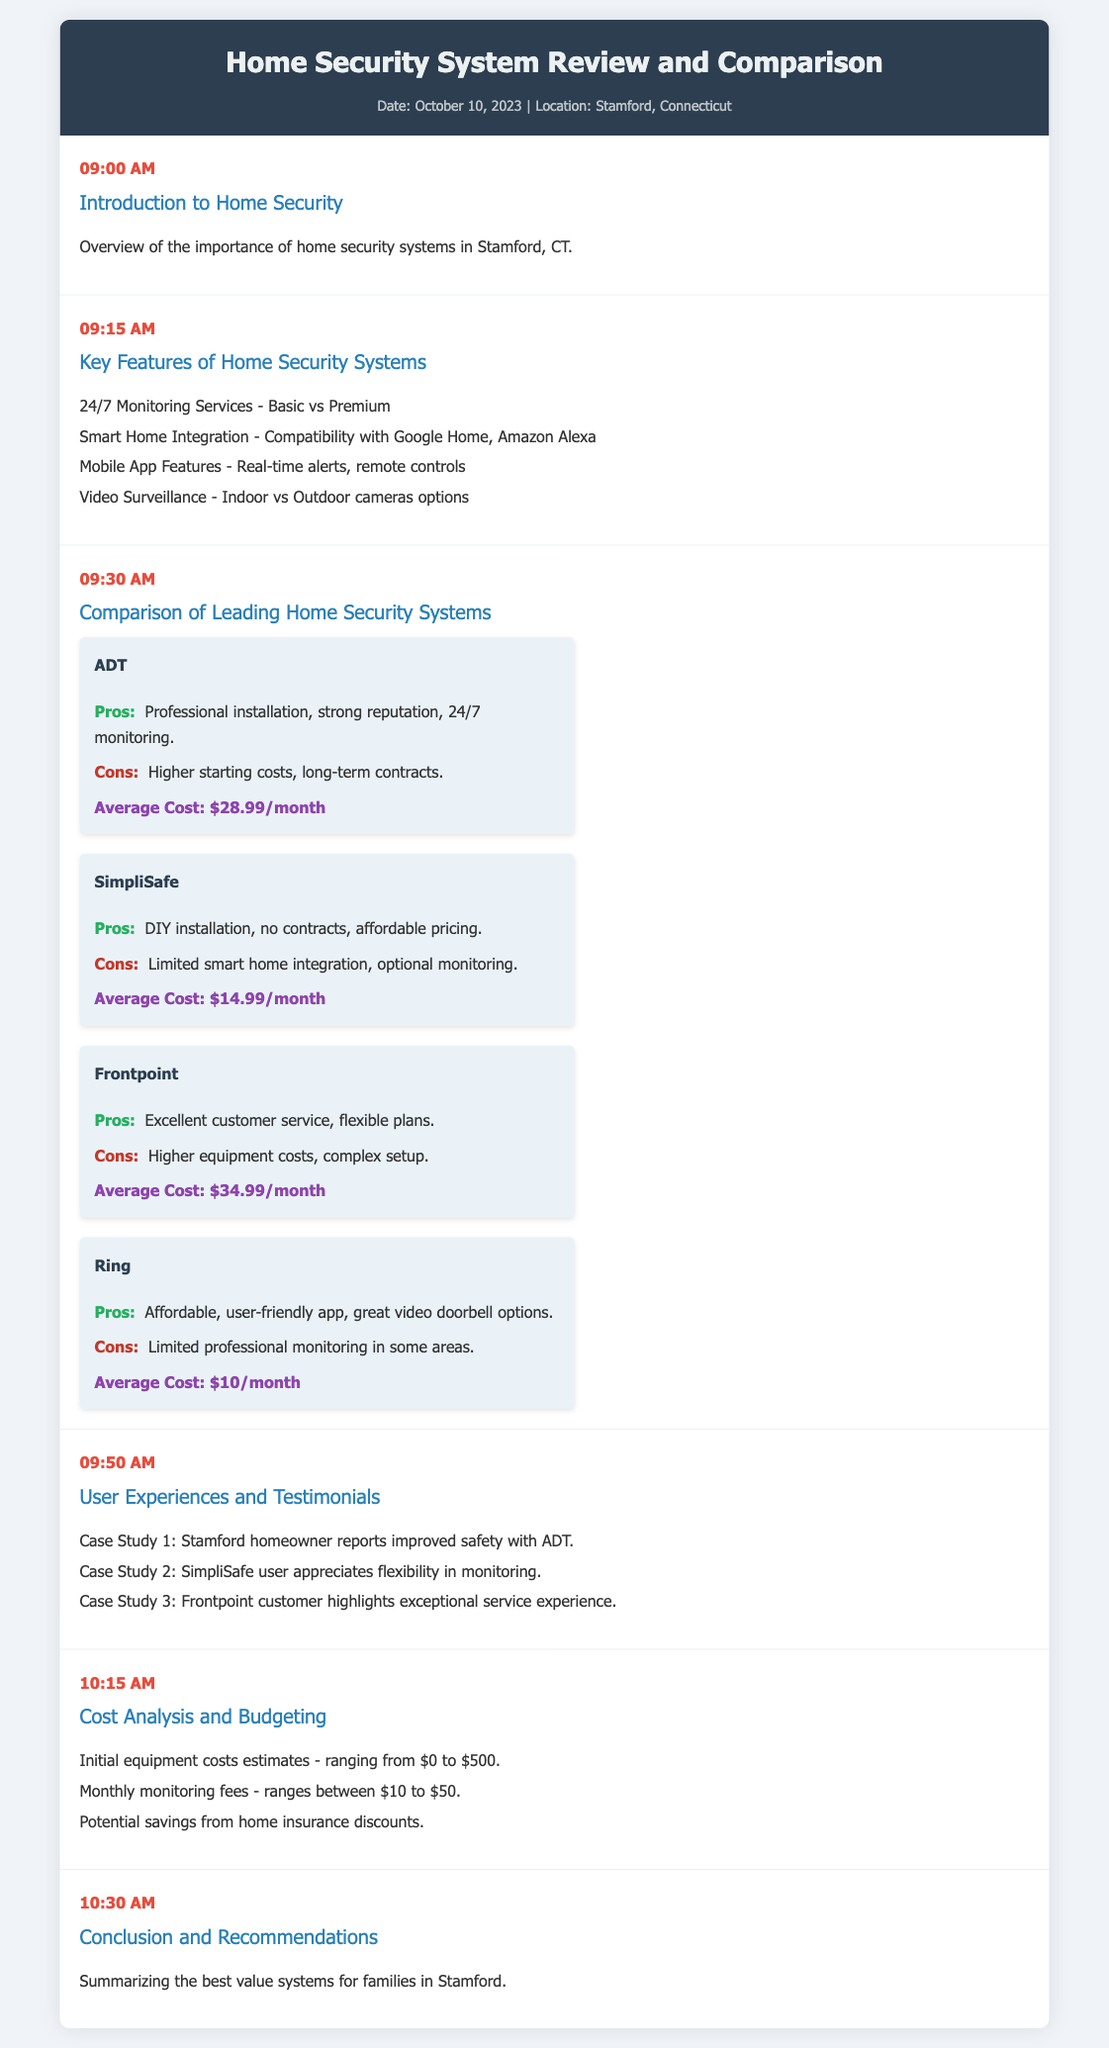What time does the introduction to home security begin? The introduction to home security starts at 09:00 AM according to the agenda.
Answer: 09:00 AM What is the average monthly cost for Ring? The average monthly cost for Ring is provided in the comparison section of the document.
Answer: $10/month Which system offers a professional installation? The system offering professional installation is mentioned in the "Comparison of Leading Home Security Systems" section.
Answer: ADT What are the two main types of monitoring services mentioned? The agenda outlines the difference between basic and premium monitoring services under key features.
Answer: Basic vs Premium Which company's customer highlights exceptional service experience? In the User Experiences section, one customer emphasizes exceptional service from a particular company.
Answer: Frontpoint What is a reason for SimpliSafe's popularity? The pros for SimpliSafe mention a specific reason for its appeal based on user feedback.
Answer: DIY installation What is the average cost range for initial equipment costs? The cost analysis section provides a range for initial equipment costs, which is essential for budgeting.
Answer: $0 to $500 What is the conclusion about the best value systems? The conclusion summarizing the best value systems for families will be discussed later in the agenda.
Answer: Best value systems for families in Stamford 